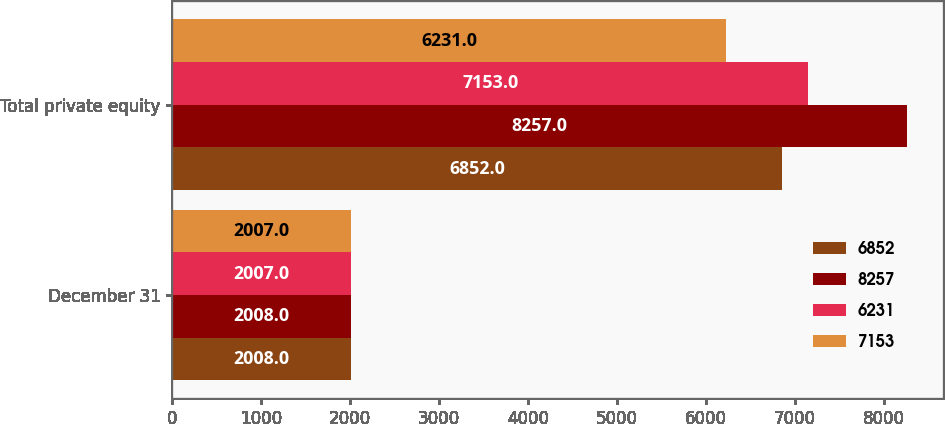<chart> <loc_0><loc_0><loc_500><loc_500><stacked_bar_chart><ecel><fcel>December 31<fcel>Total private equity<nl><fcel>6852<fcel>2008<fcel>6852<nl><fcel>8257<fcel>2008<fcel>8257<nl><fcel>6231<fcel>2007<fcel>7153<nl><fcel>7153<fcel>2007<fcel>6231<nl></chart> 